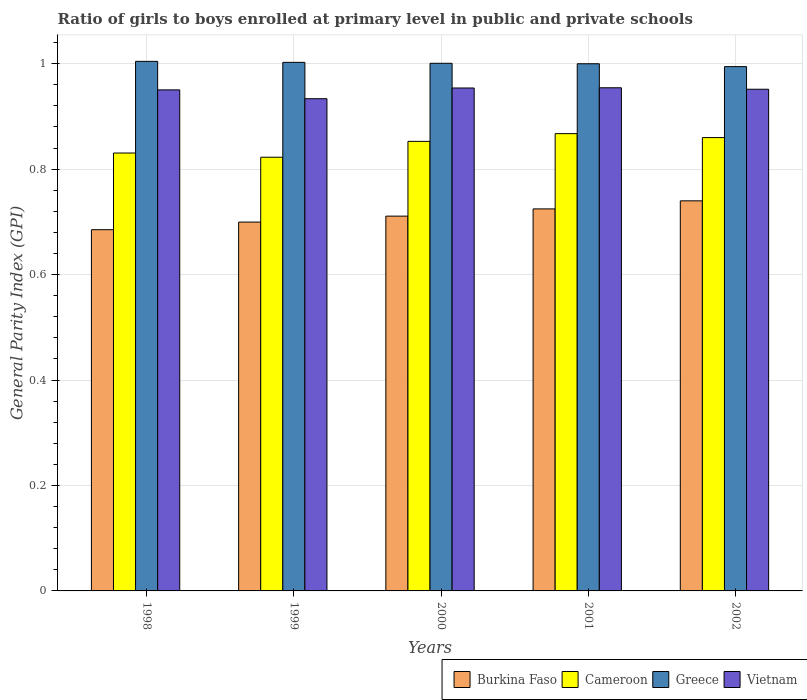How many different coloured bars are there?
Give a very brief answer. 4. Are the number of bars per tick equal to the number of legend labels?
Offer a terse response. Yes. How many bars are there on the 3rd tick from the right?
Ensure brevity in your answer.  4. What is the label of the 3rd group of bars from the left?
Make the answer very short. 2000. In how many cases, is the number of bars for a given year not equal to the number of legend labels?
Offer a very short reply. 0. What is the general parity index in Cameroon in 2000?
Ensure brevity in your answer.  0.85. Across all years, what is the maximum general parity index in Burkina Faso?
Your response must be concise. 0.74. Across all years, what is the minimum general parity index in Burkina Faso?
Your answer should be compact. 0.69. What is the total general parity index in Cameroon in the graph?
Your answer should be compact. 4.23. What is the difference between the general parity index in Cameroon in 1999 and that in 2000?
Provide a short and direct response. -0.03. What is the difference between the general parity index in Greece in 1998 and the general parity index in Burkina Faso in 1999?
Give a very brief answer. 0.3. What is the average general parity index in Vietnam per year?
Provide a short and direct response. 0.95. In the year 2001, what is the difference between the general parity index in Cameroon and general parity index in Burkina Faso?
Give a very brief answer. 0.14. What is the ratio of the general parity index in Burkina Faso in 2000 to that in 2001?
Offer a very short reply. 0.98. Is the general parity index in Burkina Faso in 2001 less than that in 2002?
Your response must be concise. Yes. What is the difference between the highest and the second highest general parity index in Vietnam?
Ensure brevity in your answer.  0. What is the difference between the highest and the lowest general parity index in Greece?
Make the answer very short. 0.01. Is it the case that in every year, the sum of the general parity index in Vietnam and general parity index in Greece is greater than the sum of general parity index in Burkina Faso and general parity index in Cameroon?
Give a very brief answer. Yes. What does the 3rd bar from the left in 2000 represents?
Provide a succinct answer. Greece. What does the 1st bar from the right in 1998 represents?
Your answer should be compact. Vietnam. How many bars are there?
Give a very brief answer. 20. What is the difference between two consecutive major ticks on the Y-axis?
Make the answer very short. 0.2. Are the values on the major ticks of Y-axis written in scientific E-notation?
Offer a terse response. No. Where does the legend appear in the graph?
Provide a short and direct response. Bottom right. What is the title of the graph?
Your answer should be compact. Ratio of girls to boys enrolled at primary level in public and private schools. What is the label or title of the Y-axis?
Offer a very short reply. General Parity Index (GPI). What is the General Parity Index (GPI) in Burkina Faso in 1998?
Ensure brevity in your answer.  0.69. What is the General Parity Index (GPI) in Cameroon in 1998?
Offer a very short reply. 0.83. What is the General Parity Index (GPI) of Greece in 1998?
Your response must be concise. 1. What is the General Parity Index (GPI) in Vietnam in 1998?
Offer a very short reply. 0.95. What is the General Parity Index (GPI) of Burkina Faso in 1999?
Make the answer very short. 0.7. What is the General Parity Index (GPI) of Cameroon in 1999?
Your answer should be compact. 0.82. What is the General Parity Index (GPI) of Greece in 1999?
Keep it short and to the point. 1. What is the General Parity Index (GPI) in Vietnam in 1999?
Your response must be concise. 0.93. What is the General Parity Index (GPI) in Burkina Faso in 2000?
Make the answer very short. 0.71. What is the General Parity Index (GPI) of Cameroon in 2000?
Provide a succinct answer. 0.85. What is the General Parity Index (GPI) of Greece in 2000?
Give a very brief answer. 1. What is the General Parity Index (GPI) in Vietnam in 2000?
Your response must be concise. 0.95. What is the General Parity Index (GPI) in Burkina Faso in 2001?
Provide a short and direct response. 0.72. What is the General Parity Index (GPI) in Cameroon in 2001?
Provide a short and direct response. 0.87. What is the General Parity Index (GPI) in Greece in 2001?
Make the answer very short. 1. What is the General Parity Index (GPI) in Vietnam in 2001?
Your response must be concise. 0.95. What is the General Parity Index (GPI) of Burkina Faso in 2002?
Your answer should be very brief. 0.74. What is the General Parity Index (GPI) in Cameroon in 2002?
Provide a short and direct response. 0.86. What is the General Parity Index (GPI) in Greece in 2002?
Ensure brevity in your answer.  0.99. What is the General Parity Index (GPI) of Vietnam in 2002?
Your answer should be very brief. 0.95. Across all years, what is the maximum General Parity Index (GPI) in Burkina Faso?
Your response must be concise. 0.74. Across all years, what is the maximum General Parity Index (GPI) of Cameroon?
Provide a succinct answer. 0.87. Across all years, what is the maximum General Parity Index (GPI) in Greece?
Make the answer very short. 1. Across all years, what is the maximum General Parity Index (GPI) in Vietnam?
Give a very brief answer. 0.95. Across all years, what is the minimum General Parity Index (GPI) of Burkina Faso?
Your answer should be very brief. 0.69. Across all years, what is the minimum General Parity Index (GPI) of Cameroon?
Offer a very short reply. 0.82. Across all years, what is the minimum General Parity Index (GPI) of Greece?
Keep it short and to the point. 0.99. Across all years, what is the minimum General Parity Index (GPI) of Vietnam?
Offer a terse response. 0.93. What is the total General Parity Index (GPI) in Burkina Faso in the graph?
Your answer should be compact. 3.56. What is the total General Parity Index (GPI) of Cameroon in the graph?
Provide a short and direct response. 4.23. What is the total General Parity Index (GPI) in Greece in the graph?
Provide a short and direct response. 5. What is the total General Parity Index (GPI) in Vietnam in the graph?
Provide a succinct answer. 4.74. What is the difference between the General Parity Index (GPI) of Burkina Faso in 1998 and that in 1999?
Keep it short and to the point. -0.01. What is the difference between the General Parity Index (GPI) of Cameroon in 1998 and that in 1999?
Your response must be concise. 0.01. What is the difference between the General Parity Index (GPI) of Greece in 1998 and that in 1999?
Your answer should be compact. 0. What is the difference between the General Parity Index (GPI) in Vietnam in 1998 and that in 1999?
Offer a terse response. 0.02. What is the difference between the General Parity Index (GPI) of Burkina Faso in 1998 and that in 2000?
Your answer should be very brief. -0.03. What is the difference between the General Parity Index (GPI) of Cameroon in 1998 and that in 2000?
Give a very brief answer. -0.02. What is the difference between the General Parity Index (GPI) in Greece in 1998 and that in 2000?
Ensure brevity in your answer.  0. What is the difference between the General Parity Index (GPI) in Vietnam in 1998 and that in 2000?
Your answer should be compact. -0. What is the difference between the General Parity Index (GPI) of Burkina Faso in 1998 and that in 2001?
Make the answer very short. -0.04. What is the difference between the General Parity Index (GPI) in Cameroon in 1998 and that in 2001?
Your response must be concise. -0.04. What is the difference between the General Parity Index (GPI) of Greece in 1998 and that in 2001?
Your answer should be compact. 0. What is the difference between the General Parity Index (GPI) in Vietnam in 1998 and that in 2001?
Give a very brief answer. -0. What is the difference between the General Parity Index (GPI) of Burkina Faso in 1998 and that in 2002?
Ensure brevity in your answer.  -0.05. What is the difference between the General Parity Index (GPI) in Cameroon in 1998 and that in 2002?
Offer a terse response. -0.03. What is the difference between the General Parity Index (GPI) in Greece in 1998 and that in 2002?
Your answer should be very brief. 0.01. What is the difference between the General Parity Index (GPI) in Vietnam in 1998 and that in 2002?
Keep it short and to the point. -0. What is the difference between the General Parity Index (GPI) of Burkina Faso in 1999 and that in 2000?
Offer a terse response. -0.01. What is the difference between the General Parity Index (GPI) of Cameroon in 1999 and that in 2000?
Ensure brevity in your answer.  -0.03. What is the difference between the General Parity Index (GPI) in Greece in 1999 and that in 2000?
Give a very brief answer. 0. What is the difference between the General Parity Index (GPI) of Vietnam in 1999 and that in 2000?
Give a very brief answer. -0.02. What is the difference between the General Parity Index (GPI) of Burkina Faso in 1999 and that in 2001?
Offer a terse response. -0.03. What is the difference between the General Parity Index (GPI) in Cameroon in 1999 and that in 2001?
Your answer should be very brief. -0.04. What is the difference between the General Parity Index (GPI) of Greece in 1999 and that in 2001?
Make the answer very short. 0. What is the difference between the General Parity Index (GPI) of Vietnam in 1999 and that in 2001?
Your answer should be compact. -0.02. What is the difference between the General Parity Index (GPI) of Burkina Faso in 1999 and that in 2002?
Offer a terse response. -0.04. What is the difference between the General Parity Index (GPI) in Cameroon in 1999 and that in 2002?
Your answer should be very brief. -0.04. What is the difference between the General Parity Index (GPI) of Greece in 1999 and that in 2002?
Provide a short and direct response. 0.01. What is the difference between the General Parity Index (GPI) in Vietnam in 1999 and that in 2002?
Offer a terse response. -0.02. What is the difference between the General Parity Index (GPI) in Burkina Faso in 2000 and that in 2001?
Offer a terse response. -0.01. What is the difference between the General Parity Index (GPI) of Cameroon in 2000 and that in 2001?
Offer a very short reply. -0.01. What is the difference between the General Parity Index (GPI) of Greece in 2000 and that in 2001?
Ensure brevity in your answer.  0. What is the difference between the General Parity Index (GPI) in Vietnam in 2000 and that in 2001?
Offer a terse response. -0. What is the difference between the General Parity Index (GPI) of Burkina Faso in 2000 and that in 2002?
Your answer should be very brief. -0.03. What is the difference between the General Parity Index (GPI) of Cameroon in 2000 and that in 2002?
Ensure brevity in your answer.  -0.01. What is the difference between the General Parity Index (GPI) in Greece in 2000 and that in 2002?
Provide a short and direct response. 0.01. What is the difference between the General Parity Index (GPI) in Vietnam in 2000 and that in 2002?
Provide a short and direct response. 0. What is the difference between the General Parity Index (GPI) of Burkina Faso in 2001 and that in 2002?
Your response must be concise. -0.02. What is the difference between the General Parity Index (GPI) in Cameroon in 2001 and that in 2002?
Make the answer very short. 0.01. What is the difference between the General Parity Index (GPI) of Greece in 2001 and that in 2002?
Your response must be concise. 0.01. What is the difference between the General Parity Index (GPI) of Vietnam in 2001 and that in 2002?
Provide a succinct answer. 0. What is the difference between the General Parity Index (GPI) in Burkina Faso in 1998 and the General Parity Index (GPI) in Cameroon in 1999?
Provide a succinct answer. -0.14. What is the difference between the General Parity Index (GPI) of Burkina Faso in 1998 and the General Parity Index (GPI) of Greece in 1999?
Provide a short and direct response. -0.32. What is the difference between the General Parity Index (GPI) in Burkina Faso in 1998 and the General Parity Index (GPI) in Vietnam in 1999?
Your response must be concise. -0.25. What is the difference between the General Parity Index (GPI) in Cameroon in 1998 and the General Parity Index (GPI) in Greece in 1999?
Your response must be concise. -0.17. What is the difference between the General Parity Index (GPI) in Cameroon in 1998 and the General Parity Index (GPI) in Vietnam in 1999?
Give a very brief answer. -0.1. What is the difference between the General Parity Index (GPI) in Greece in 1998 and the General Parity Index (GPI) in Vietnam in 1999?
Your answer should be very brief. 0.07. What is the difference between the General Parity Index (GPI) of Burkina Faso in 1998 and the General Parity Index (GPI) of Cameroon in 2000?
Offer a very short reply. -0.17. What is the difference between the General Parity Index (GPI) in Burkina Faso in 1998 and the General Parity Index (GPI) in Greece in 2000?
Make the answer very short. -0.32. What is the difference between the General Parity Index (GPI) in Burkina Faso in 1998 and the General Parity Index (GPI) in Vietnam in 2000?
Provide a succinct answer. -0.27. What is the difference between the General Parity Index (GPI) of Cameroon in 1998 and the General Parity Index (GPI) of Greece in 2000?
Keep it short and to the point. -0.17. What is the difference between the General Parity Index (GPI) in Cameroon in 1998 and the General Parity Index (GPI) in Vietnam in 2000?
Ensure brevity in your answer.  -0.12. What is the difference between the General Parity Index (GPI) of Greece in 1998 and the General Parity Index (GPI) of Vietnam in 2000?
Keep it short and to the point. 0.05. What is the difference between the General Parity Index (GPI) of Burkina Faso in 1998 and the General Parity Index (GPI) of Cameroon in 2001?
Your answer should be compact. -0.18. What is the difference between the General Parity Index (GPI) in Burkina Faso in 1998 and the General Parity Index (GPI) in Greece in 2001?
Keep it short and to the point. -0.31. What is the difference between the General Parity Index (GPI) of Burkina Faso in 1998 and the General Parity Index (GPI) of Vietnam in 2001?
Provide a succinct answer. -0.27. What is the difference between the General Parity Index (GPI) of Cameroon in 1998 and the General Parity Index (GPI) of Greece in 2001?
Provide a short and direct response. -0.17. What is the difference between the General Parity Index (GPI) of Cameroon in 1998 and the General Parity Index (GPI) of Vietnam in 2001?
Keep it short and to the point. -0.12. What is the difference between the General Parity Index (GPI) of Greece in 1998 and the General Parity Index (GPI) of Vietnam in 2001?
Ensure brevity in your answer.  0.05. What is the difference between the General Parity Index (GPI) of Burkina Faso in 1998 and the General Parity Index (GPI) of Cameroon in 2002?
Your response must be concise. -0.17. What is the difference between the General Parity Index (GPI) of Burkina Faso in 1998 and the General Parity Index (GPI) of Greece in 2002?
Offer a very short reply. -0.31. What is the difference between the General Parity Index (GPI) in Burkina Faso in 1998 and the General Parity Index (GPI) in Vietnam in 2002?
Make the answer very short. -0.27. What is the difference between the General Parity Index (GPI) of Cameroon in 1998 and the General Parity Index (GPI) of Greece in 2002?
Make the answer very short. -0.16. What is the difference between the General Parity Index (GPI) of Cameroon in 1998 and the General Parity Index (GPI) of Vietnam in 2002?
Your response must be concise. -0.12. What is the difference between the General Parity Index (GPI) of Greece in 1998 and the General Parity Index (GPI) of Vietnam in 2002?
Provide a short and direct response. 0.05. What is the difference between the General Parity Index (GPI) in Burkina Faso in 1999 and the General Parity Index (GPI) in Cameroon in 2000?
Your answer should be very brief. -0.15. What is the difference between the General Parity Index (GPI) of Burkina Faso in 1999 and the General Parity Index (GPI) of Greece in 2000?
Your answer should be compact. -0.3. What is the difference between the General Parity Index (GPI) of Burkina Faso in 1999 and the General Parity Index (GPI) of Vietnam in 2000?
Offer a very short reply. -0.25. What is the difference between the General Parity Index (GPI) of Cameroon in 1999 and the General Parity Index (GPI) of Greece in 2000?
Make the answer very short. -0.18. What is the difference between the General Parity Index (GPI) of Cameroon in 1999 and the General Parity Index (GPI) of Vietnam in 2000?
Offer a very short reply. -0.13. What is the difference between the General Parity Index (GPI) in Greece in 1999 and the General Parity Index (GPI) in Vietnam in 2000?
Keep it short and to the point. 0.05. What is the difference between the General Parity Index (GPI) in Burkina Faso in 1999 and the General Parity Index (GPI) in Cameroon in 2001?
Offer a very short reply. -0.17. What is the difference between the General Parity Index (GPI) in Burkina Faso in 1999 and the General Parity Index (GPI) in Greece in 2001?
Offer a terse response. -0.3. What is the difference between the General Parity Index (GPI) in Burkina Faso in 1999 and the General Parity Index (GPI) in Vietnam in 2001?
Provide a succinct answer. -0.25. What is the difference between the General Parity Index (GPI) of Cameroon in 1999 and the General Parity Index (GPI) of Greece in 2001?
Make the answer very short. -0.18. What is the difference between the General Parity Index (GPI) of Cameroon in 1999 and the General Parity Index (GPI) of Vietnam in 2001?
Give a very brief answer. -0.13. What is the difference between the General Parity Index (GPI) in Greece in 1999 and the General Parity Index (GPI) in Vietnam in 2001?
Give a very brief answer. 0.05. What is the difference between the General Parity Index (GPI) of Burkina Faso in 1999 and the General Parity Index (GPI) of Cameroon in 2002?
Give a very brief answer. -0.16. What is the difference between the General Parity Index (GPI) of Burkina Faso in 1999 and the General Parity Index (GPI) of Greece in 2002?
Offer a terse response. -0.29. What is the difference between the General Parity Index (GPI) of Burkina Faso in 1999 and the General Parity Index (GPI) of Vietnam in 2002?
Make the answer very short. -0.25. What is the difference between the General Parity Index (GPI) of Cameroon in 1999 and the General Parity Index (GPI) of Greece in 2002?
Your answer should be very brief. -0.17. What is the difference between the General Parity Index (GPI) in Cameroon in 1999 and the General Parity Index (GPI) in Vietnam in 2002?
Provide a short and direct response. -0.13. What is the difference between the General Parity Index (GPI) in Greece in 1999 and the General Parity Index (GPI) in Vietnam in 2002?
Your response must be concise. 0.05. What is the difference between the General Parity Index (GPI) in Burkina Faso in 2000 and the General Parity Index (GPI) in Cameroon in 2001?
Offer a very short reply. -0.16. What is the difference between the General Parity Index (GPI) of Burkina Faso in 2000 and the General Parity Index (GPI) of Greece in 2001?
Ensure brevity in your answer.  -0.29. What is the difference between the General Parity Index (GPI) in Burkina Faso in 2000 and the General Parity Index (GPI) in Vietnam in 2001?
Keep it short and to the point. -0.24. What is the difference between the General Parity Index (GPI) in Cameroon in 2000 and the General Parity Index (GPI) in Greece in 2001?
Your answer should be very brief. -0.15. What is the difference between the General Parity Index (GPI) of Cameroon in 2000 and the General Parity Index (GPI) of Vietnam in 2001?
Offer a terse response. -0.1. What is the difference between the General Parity Index (GPI) in Greece in 2000 and the General Parity Index (GPI) in Vietnam in 2001?
Offer a terse response. 0.05. What is the difference between the General Parity Index (GPI) of Burkina Faso in 2000 and the General Parity Index (GPI) of Cameroon in 2002?
Your answer should be compact. -0.15. What is the difference between the General Parity Index (GPI) in Burkina Faso in 2000 and the General Parity Index (GPI) in Greece in 2002?
Your response must be concise. -0.28. What is the difference between the General Parity Index (GPI) of Burkina Faso in 2000 and the General Parity Index (GPI) of Vietnam in 2002?
Keep it short and to the point. -0.24. What is the difference between the General Parity Index (GPI) of Cameroon in 2000 and the General Parity Index (GPI) of Greece in 2002?
Provide a short and direct response. -0.14. What is the difference between the General Parity Index (GPI) of Cameroon in 2000 and the General Parity Index (GPI) of Vietnam in 2002?
Ensure brevity in your answer.  -0.1. What is the difference between the General Parity Index (GPI) of Greece in 2000 and the General Parity Index (GPI) of Vietnam in 2002?
Keep it short and to the point. 0.05. What is the difference between the General Parity Index (GPI) of Burkina Faso in 2001 and the General Parity Index (GPI) of Cameroon in 2002?
Provide a succinct answer. -0.14. What is the difference between the General Parity Index (GPI) of Burkina Faso in 2001 and the General Parity Index (GPI) of Greece in 2002?
Your response must be concise. -0.27. What is the difference between the General Parity Index (GPI) in Burkina Faso in 2001 and the General Parity Index (GPI) in Vietnam in 2002?
Offer a very short reply. -0.23. What is the difference between the General Parity Index (GPI) in Cameroon in 2001 and the General Parity Index (GPI) in Greece in 2002?
Offer a very short reply. -0.13. What is the difference between the General Parity Index (GPI) of Cameroon in 2001 and the General Parity Index (GPI) of Vietnam in 2002?
Your answer should be very brief. -0.08. What is the difference between the General Parity Index (GPI) of Greece in 2001 and the General Parity Index (GPI) of Vietnam in 2002?
Provide a short and direct response. 0.05. What is the average General Parity Index (GPI) of Burkina Faso per year?
Ensure brevity in your answer.  0.71. What is the average General Parity Index (GPI) of Cameroon per year?
Your answer should be compact. 0.85. What is the average General Parity Index (GPI) of Vietnam per year?
Your response must be concise. 0.95. In the year 1998, what is the difference between the General Parity Index (GPI) in Burkina Faso and General Parity Index (GPI) in Cameroon?
Your response must be concise. -0.15. In the year 1998, what is the difference between the General Parity Index (GPI) in Burkina Faso and General Parity Index (GPI) in Greece?
Provide a succinct answer. -0.32. In the year 1998, what is the difference between the General Parity Index (GPI) of Burkina Faso and General Parity Index (GPI) of Vietnam?
Your answer should be compact. -0.27. In the year 1998, what is the difference between the General Parity Index (GPI) of Cameroon and General Parity Index (GPI) of Greece?
Your response must be concise. -0.17. In the year 1998, what is the difference between the General Parity Index (GPI) of Cameroon and General Parity Index (GPI) of Vietnam?
Your response must be concise. -0.12. In the year 1998, what is the difference between the General Parity Index (GPI) of Greece and General Parity Index (GPI) of Vietnam?
Keep it short and to the point. 0.05. In the year 1999, what is the difference between the General Parity Index (GPI) in Burkina Faso and General Parity Index (GPI) in Cameroon?
Give a very brief answer. -0.12. In the year 1999, what is the difference between the General Parity Index (GPI) in Burkina Faso and General Parity Index (GPI) in Greece?
Offer a very short reply. -0.3. In the year 1999, what is the difference between the General Parity Index (GPI) of Burkina Faso and General Parity Index (GPI) of Vietnam?
Provide a short and direct response. -0.23. In the year 1999, what is the difference between the General Parity Index (GPI) of Cameroon and General Parity Index (GPI) of Greece?
Your answer should be compact. -0.18. In the year 1999, what is the difference between the General Parity Index (GPI) in Cameroon and General Parity Index (GPI) in Vietnam?
Your response must be concise. -0.11. In the year 1999, what is the difference between the General Parity Index (GPI) of Greece and General Parity Index (GPI) of Vietnam?
Give a very brief answer. 0.07. In the year 2000, what is the difference between the General Parity Index (GPI) of Burkina Faso and General Parity Index (GPI) of Cameroon?
Provide a succinct answer. -0.14. In the year 2000, what is the difference between the General Parity Index (GPI) in Burkina Faso and General Parity Index (GPI) in Greece?
Ensure brevity in your answer.  -0.29. In the year 2000, what is the difference between the General Parity Index (GPI) in Burkina Faso and General Parity Index (GPI) in Vietnam?
Offer a very short reply. -0.24. In the year 2000, what is the difference between the General Parity Index (GPI) in Cameroon and General Parity Index (GPI) in Greece?
Provide a succinct answer. -0.15. In the year 2000, what is the difference between the General Parity Index (GPI) in Cameroon and General Parity Index (GPI) in Vietnam?
Give a very brief answer. -0.1. In the year 2000, what is the difference between the General Parity Index (GPI) of Greece and General Parity Index (GPI) of Vietnam?
Make the answer very short. 0.05. In the year 2001, what is the difference between the General Parity Index (GPI) of Burkina Faso and General Parity Index (GPI) of Cameroon?
Provide a short and direct response. -0.14. In the year 2001, what is the difference between the General Parity Index (GPI) of Burkina Faso and General Parity Index (GPI) of Greece?
Ensure brevity in your answer.  -0.28. In the year 2001, what is the difference between the General Parity Index (GPI) of Burkina Faso and General Parity Index (GPI) of Vietnam?
Provide a succinct answer. -0.23. In the year 2001, what is the difference between the General Parity Index (GPI) in Cameroon and General Parity Index (GPI) in Greece?
Offer a terse response. -0.13. In the year 2001, what is the difference between the General Parity Index (GPI) in Cameroon and General Parity Index (GPI) in Vietnam?
Offer a very short reply. -0.09. In the year 2001, what is the difference between the General Parity Index (GPI) of Greece and General Parity Index (GPI) of Vietnam?
Offer a terse response. 0.05. In the year 2002, what is the difference between the General Parity Index (GPI) in Burkina Faso and General Parity Index (GPI) in Cameroon?
Provide a succinct answer. -0.12. In the year 2002, what is the difference between the General Parity Index (GPI) of Burkina Faso and General Parity Index (GPI) of Greece?
Your response must be concise. -0.25. In the year 2002, what is the difference between the General Parity Index (GPI) of Burkina Faso and General Parity Index (GPI) of Vietnam?
Your answer should be compact. -0.21. In the year 2002, what is the difference between the General Parity Index (GPI) in Cameroon and General Parity Index (GPI) in Greece?
Provide a succinct answer. -0.13. In the year 2002, what is the difference between the General Parity Index (GPI) in Cameroon and General Parity Index (GPI) in Vietnam?
Ensure brevity in your answer.  -0.09. In the year 2002, what is the difference between the General Parity Index (GPI) in Greece and General Parity Index (GPI) in Vietnam?
Provide a succinct answer. 0.04. What is the ratio of the General Parity Index (GPI) of Burkina Faso in 1998 to that in 1999?
Give a very brief answer. 0.98. What is the ratio of the General Parity Index (GPI) in Cameroon in 1998 to that in 1999?
Provide a succinct answer. 1.01. What is the ratio of the General Parity Index (GPI) in Greece in 1998 to that in 1999?
Provide a succinct answer. 1. What is the ratio of the General Parity Index (GPI) in Vietnam in 1998 to that in 1999?
Provide a short and direct response. 1.02. What is the ratio of the General Parity Index (GPI) of Burkina Faso in 1998 to that in 2000?
Provide a short and direct response. 0.96. What is the ratio of the General Parity Index (GPI) of Cameroon in 1998 to that in 2000?
Your answer should be compact. 0.97. What is the ratio of the General Parity Index (GPI) in Vietnam in 1998 to that in 2000?
Ensure brevity in your answer.  1. What is the ratio of the General Parity Index (GPI) in Burkina Faso in 1998 to that in 2001?
Your answer should be very brief. 0.95. What is the ratio of the General Parity Index (GPI) in Cameroon in 1998 to that in 2001?
Make the answer very short. 0.96. What is the ratio of the General Parity Index (GPI) of Greece in 1998 to that in 2001?
Provide a succinct answer. 1. What is the ratio of the General Parity Index (GPI) of Vietnam in 1998 to that in 2001?
Your answer should be compact. 1. What is the ratio of the General Parity Index (GPI) of Burkina Faso in 1998 to that in 2002?
Make the answer very short. 0.93. What is the ratio of the General Parity Index (GPI) in Cameroon in 1998 to that in 2002?
Ensure brevity in your answer.  0.97. What is the ratio of the General Parity Index (GPI) in Greece in 1998 to that in 2002?
Provide a succinct answer. 1.01. What is the ratio of the General Parity Index (GPI) in Burkina Faso in 1999 to that in 2000?
Make the answer very short. 0.98. What is the ratio of the General Parity Index (GPI) in Cameroon in 1999 to that in 2000?
Offer a terse response. 0.96. What is the ratio of the General Parity Index (GPI) in Greece in 1999 to that in 2000?
Ensure brevity in your answer.  1. What is the ratio of the General Parity Index (GPI) in Vietnam in 1999 to that in 2000?
Your response must be concise. 0.98. What is the ratio of the General Parity Index (GPI) of Burkina Faso in 1999 to that in 2001?
Make the answer very short. 0.97. What is the ratio of the General Parity Index (GPI) of Cameroon in 1999 to that in 2001?
Provide a short and direct response. 0.95. What is the ratio of the General Parity Index (GPI) in Greece in 1999 to that in 2001?
Keep it short and to the point. 1. What is the ratio of the General Parity Index (GPI) in Vietnam in 1999 to that in 2001?
Provide a short and direct response. 0.98. What is the ratio of the General Parity Index (GPI) in Burkina Faso in 1999 to that in 2002?
Give a very brief answer. 0.95. What is the ratio of the General Parity Index (GPI) in Cameroon in 1999 to that in 2002?
Keep it short and to the point. 0.96. What is the ratio of the General Parity Index (GPI) in Greece in 1999 to that in 2002?
Provide a short and direct response. 1.01. What is the ratio of the General Parity Index (GPI) of Vietnam in 1999 to that in 2002?
Your response must be concise. 0.98. What is the ratio of the General Parity Index (GPI) in Burkina Faso in 2000 to that in 2001?
Your answer should be compact. 0.98. What is the ratio of the General Parity Index (GPI) of Cameroon in 2000 to that in 2001?
Give a very brief answer. 0.98. What is the ratio of the General Parity Index (GPI) of Greece in 2000 to that in 2001?
Make the answer very short. 1. What is the ratio of the General Parity Index (GPI) in Burkina Faso in 2000 to that in 2002?
Your response must be concise. 0.96. What is the ratio of the General Parity Index (GPI) of Greece in 2000 to that in 2002?
Make the answer very short. 1.01. What is the ratio of the General Parity Index (GPI) of Burkina Faso in 2001 to that in 2002?
Offer a very short reply. 0.98. What is the ratio of the General Parity Index (GPI) in Cameroon in 2001 to that in 2002?
Ensure brevity in your answer.  1.01. What is the difference between the highest and the second highest General Parity Index (GPI) in Burkina Faso?
Make the answer very short. 0.02. What is the difference between the highest and the second highest General Parity Index (GPI) of Cameroon?
Your answer should be very brief. 0.01. What is the difference between the highest and the second highest General Parity Index (GPI) in Greece?
Offer a terse response. 0. What is the difference between the highest and the second highest General Parity Index (GPI) of Vietnam?
Your answer should be compact. 0. What is the difference between the highest and the lowest General Parity Index (GPI) in Burkina Faso?
Ensure brevity in your answer.  0.05. What is the difference between the highest and the lowest General Parity Index (GPI) of Cameroon?
Your answer should be very brief. 0.04. What is the difference between the highest and the lowest General Parity Index (GPI) of Greece?
Keep it short and to the point. 0.01. What is the difference between the highest and the lowest General Parity Index (GPI) in Vietnam?
Offer a terse response. 0.02. 